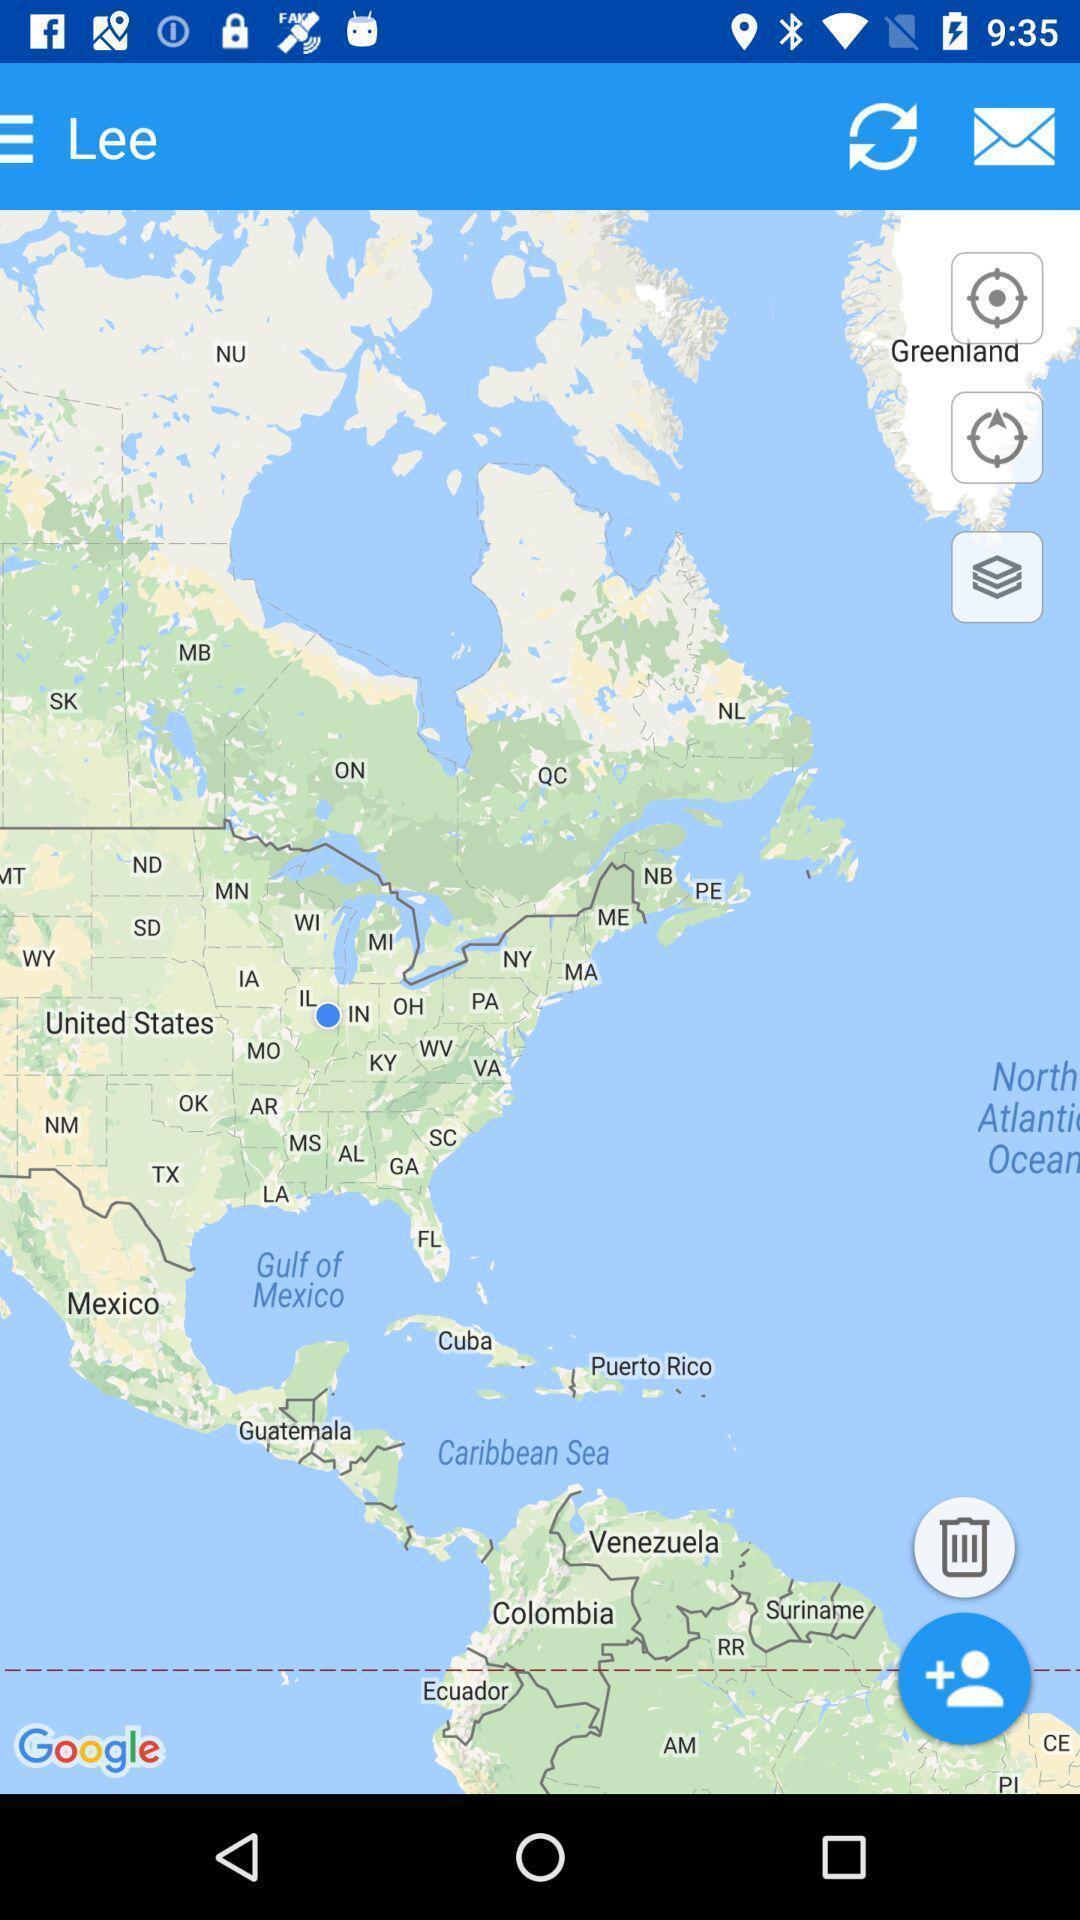Give me a summary of this screen capture. Page shows multiple options in a mapping application. 